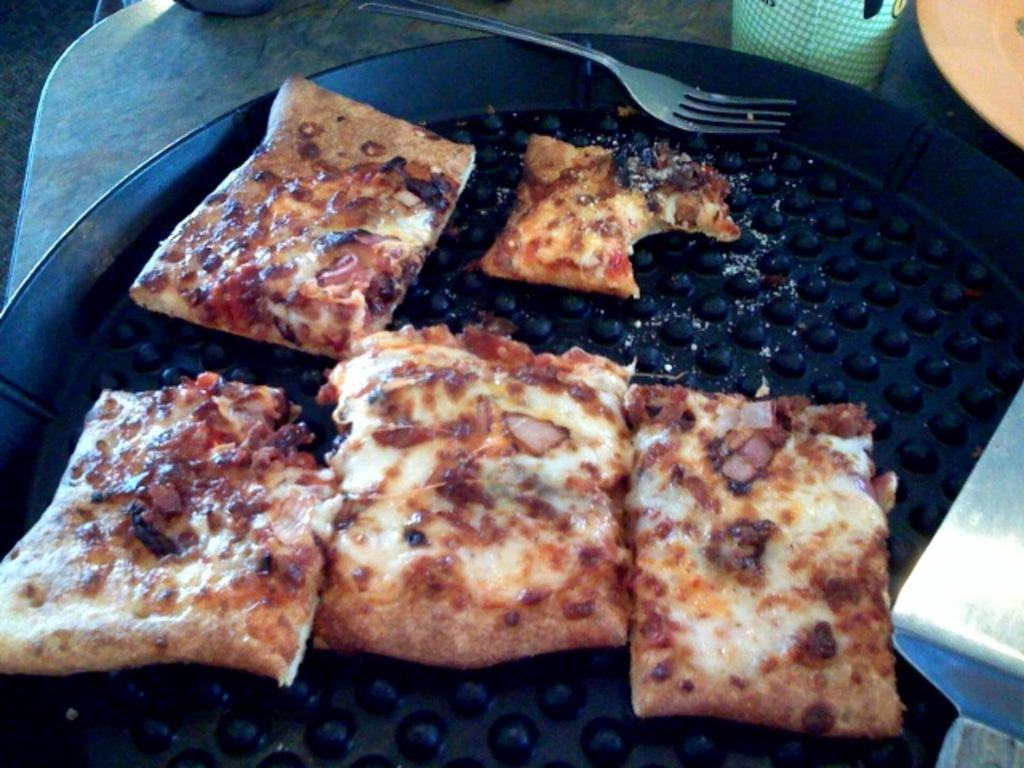What type of food is present in the image? There is a flatbread in the image. What utensil can be seen in the image? A fork is visible in the image. What is the flatbread placed on in the image? There is a plate in the image. What is the glass used for in the image? The glass is likely used for holding a beverage. Where are the plate and glass located in the image? The plate and glass are placed on a table. What type of protest is taking place in the image? There is no protest present in the image; it features a flatbread, fork, plate, glass, and table. How many bridges can be seen in the image? There are no bridges present in the image. 